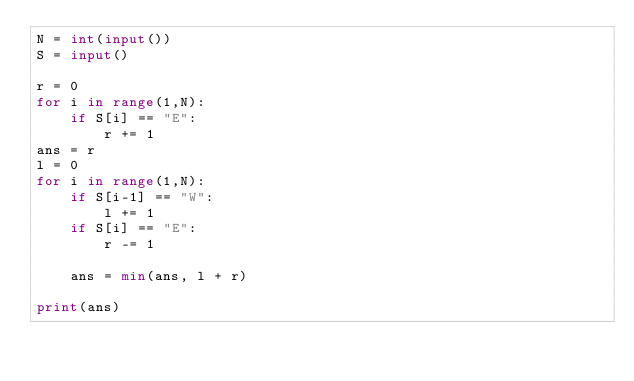<code> <loc_0><loc_0><loc_500><loc_500><_Python_>N = int(input())
S = input()

r = 0
for i in range(1,N):
    if S[i] == "E":
        r += 1
ans = r
l = 0
for i in range(1,N):
    if S[i-1] == "W":
        l += 1
    if S[i] == "E":
        r -= 1
        
    ans = min(ans, l + r)

print(ans)</code> 